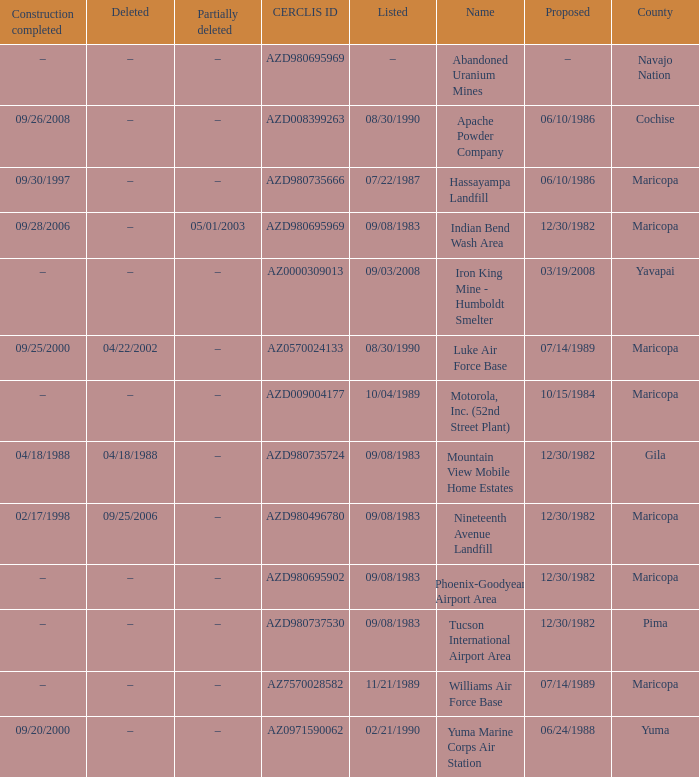What is the date when the site was listed in cochise county? 08/30/1990. 